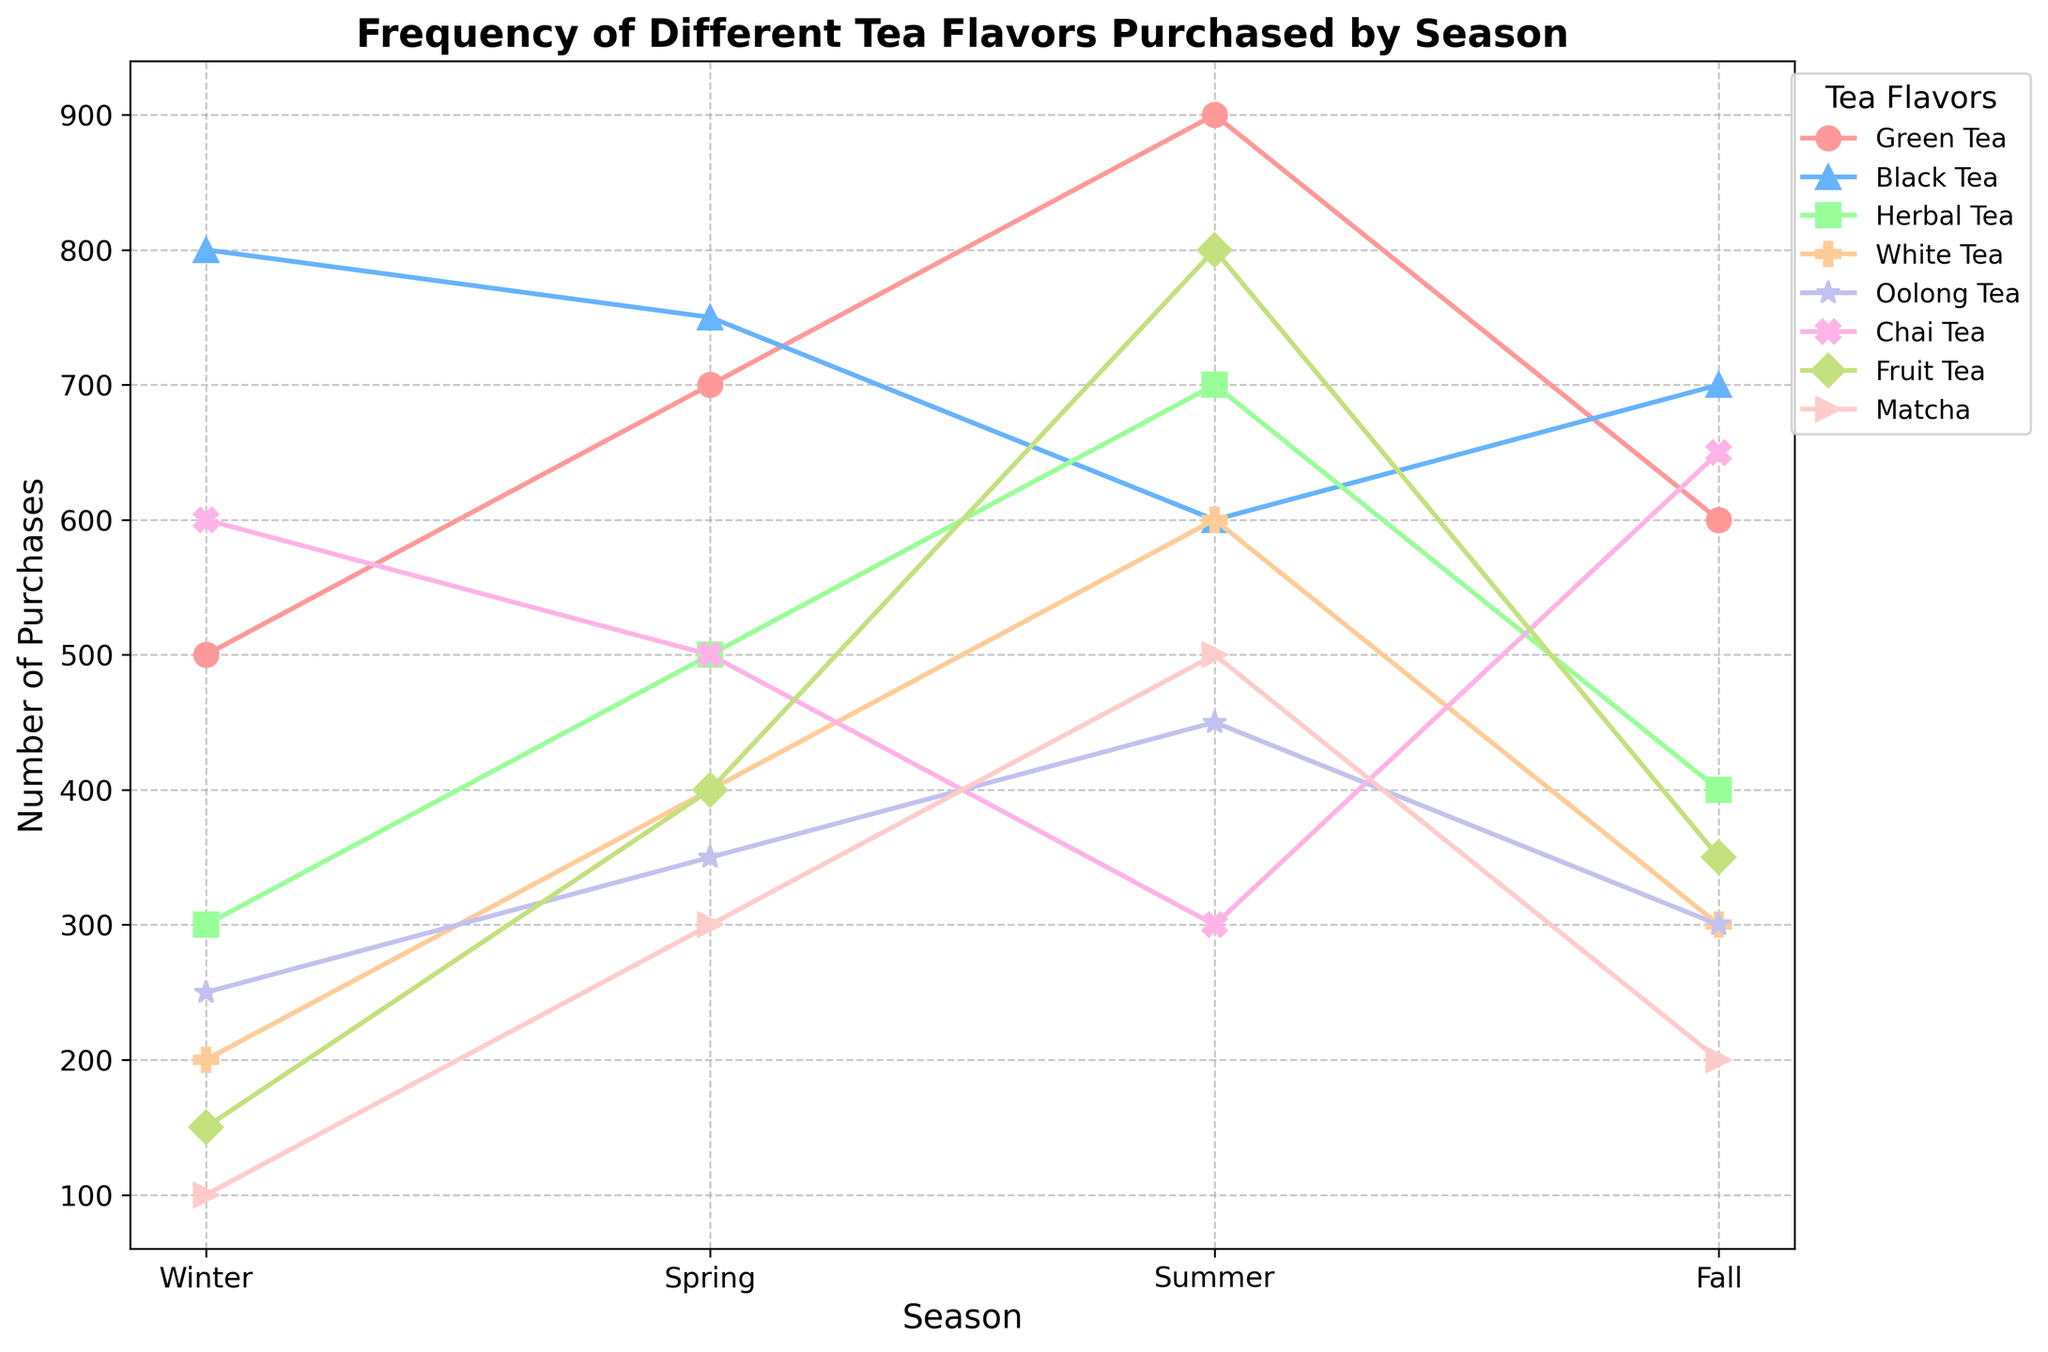Which flavor of tea has the highest number of purchases in Summer? To answer this, look at the highest point on the graph for the Summer season. The flavor with the highest point is "Green Tea" with 900 purchases.
Answer: Green Tea Which tea flavor has the least number of purchases in Spring? Look for the lowest point on the graph for the Spring season. "Matcha" has the least number of purchases with 300 purchases.
Answer: Matcha What is the average number of Black Tea purchases over the four seasons? Sum the number of Black Tea purchases for all four seasons and divide by 4. (800 + 750 + 600 + 700) / 4 = 2875 / 4 = 712.5
Answer: 712.5 Which tea flavor has the greatest variation in the number of purchases across all seasons? To find the greatest variation, identify the flavor with the largest difference between its highest and lowest purchase counts. Green Tea varies from 500 to 900, Black Tea from 600 to 800, Herbal Tea from 300 to 700, and so on. Green Tea has the highest variation (900 - 500 = 400).
Answer: Green Tea How many flavors have more purchases in Summer than in Winter? Count the flavors where the Summer purchases exceed Winter purchases. These flavors are Green Tea, Herbal Tea, White Tea, Oolong Tea, Fruit Tea, and Matcha. There are 6 such flavors.
Answer: 6 Which season has the highest total tea purchases across all flavors? Sum the purchases for each season: Winter (500 + 800 + 300 + 200 + 250 + 600 + 150 + 100), Spring (700 + 750 + 500 + 400 + 350 + 500 + 400 + 300), Summer (900 + 600 + 700 + 600 + 450 + 300 + 800 + 500), Fall (600 + 700 + 400 + 300 + 300 + 650 + 350 + 200). The totals are Winter: 2900, Spring: 3900, Summer: 5350, and Fall: 3500. Summer has the highest total.
Answer: Summer Does Chai Tea have more purchases in Fall or Winter? Compare the number of purchases. In Fall, Chai Tea has 650 purchases, and in Winter, it has 600 purchases. Therefore, it has more in Fall.
Answer: Fall For which flavor is the difference between Winter and Fall purchases the smallest? Calculate the difference for each flavor and compare: Green Tea (500-600=100), Black Tea (800-700=100), Herbal Tea (300-400=100), White Tea (200-300=100), Oolong Tea (250-300=50), Chai Tea (600-650=50), Fruit Tea (150-350=200), Matcha (100-200=100). Oolong Tea and Chai Tea have the smallest difference with a difference of 50.
Answer: Oolong Tea and Chai Tea 